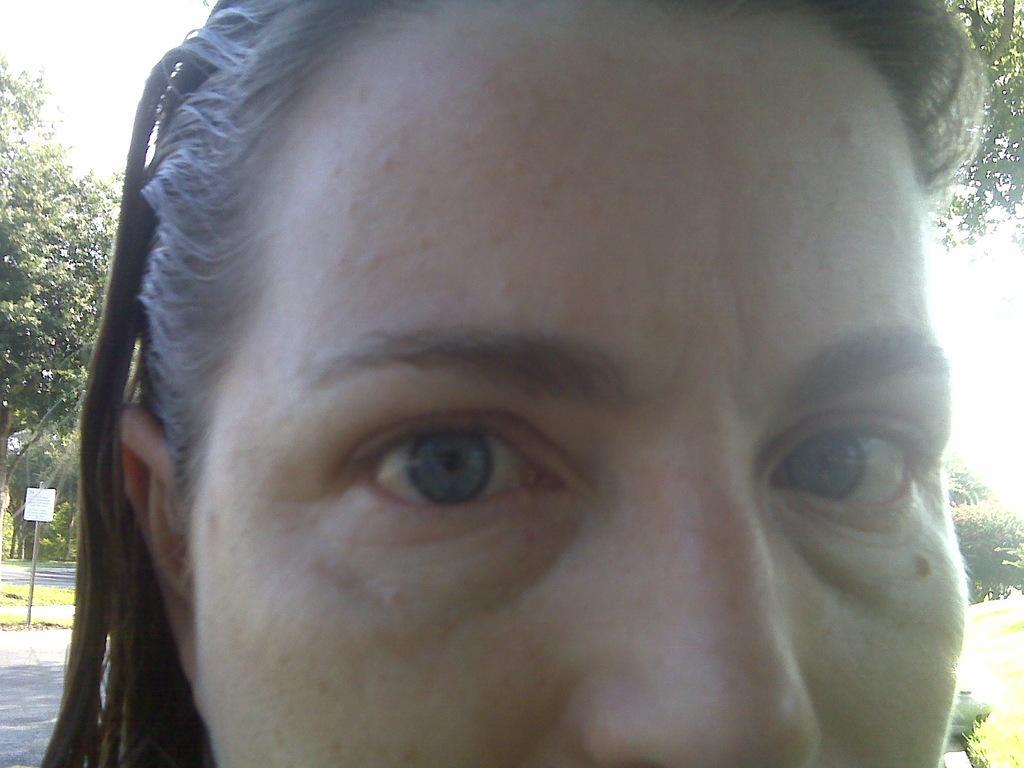Please provide a concise description of this image. In the center of the image we can see one person face. In the background, we can see the sky, clouds, trees, road, one pole, one sign board and a few other objects. 